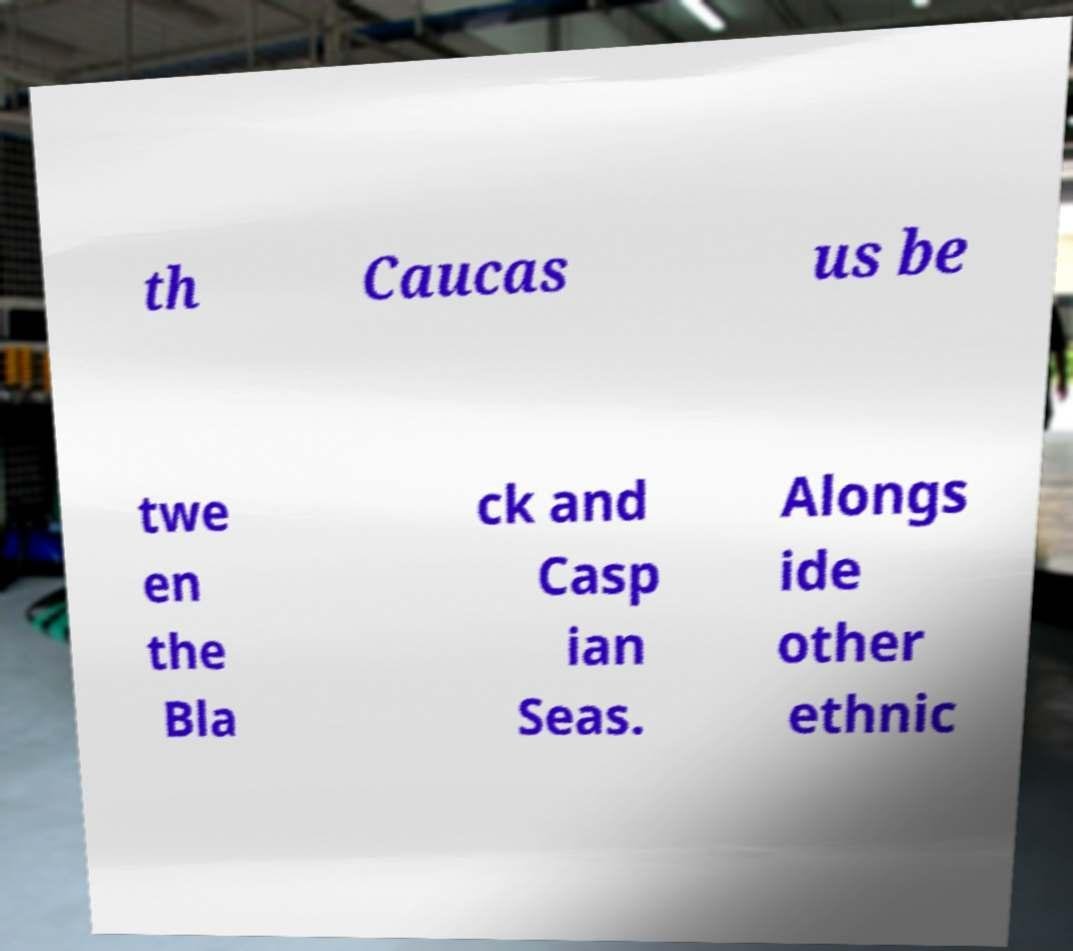For documentation purposes, I need the text within this image transcribed. Could you provide that? th Caucas us be twe en the Bla ck and Casp ian Seas. Alongs ide other ethnic 